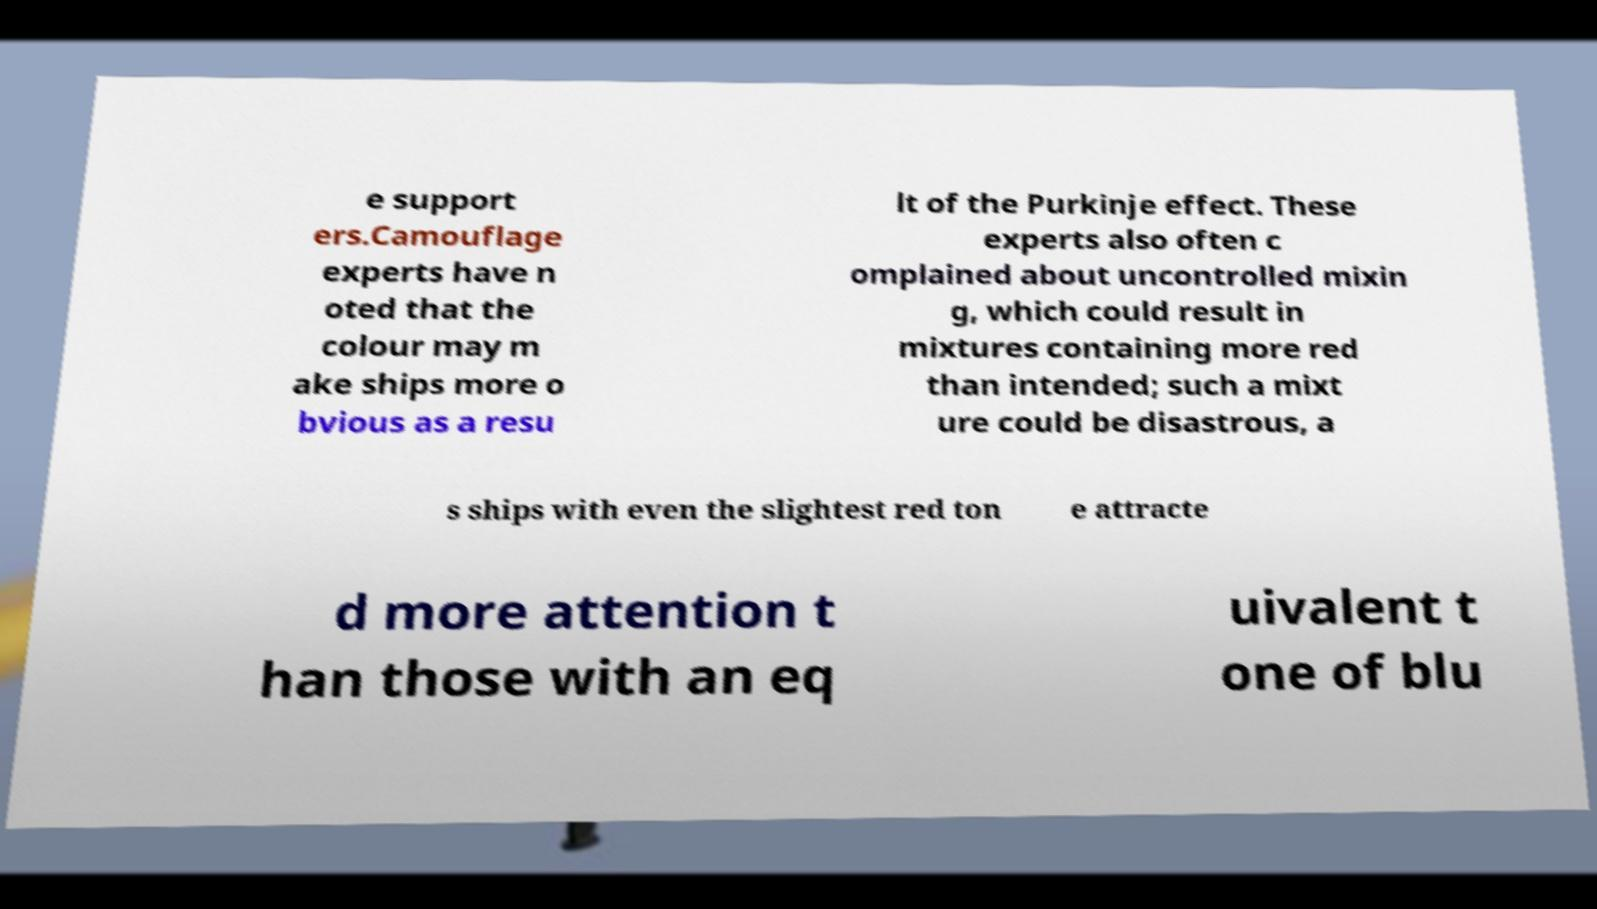I need the written content from this picture converted into text. Can you do that? e support ers.Camouflage experts have n oted that the colour may m ake ships more o bvious as a resu lt of the Purkinje effect. These experts also often c omplained about uncontrolled mixin g, which could result in mixtures containing more red than intended; such a mixt ure could be disastrous, a s ships with even the slightest red ton e attracte d more attention t han those with an eq uivalent t one of blu 